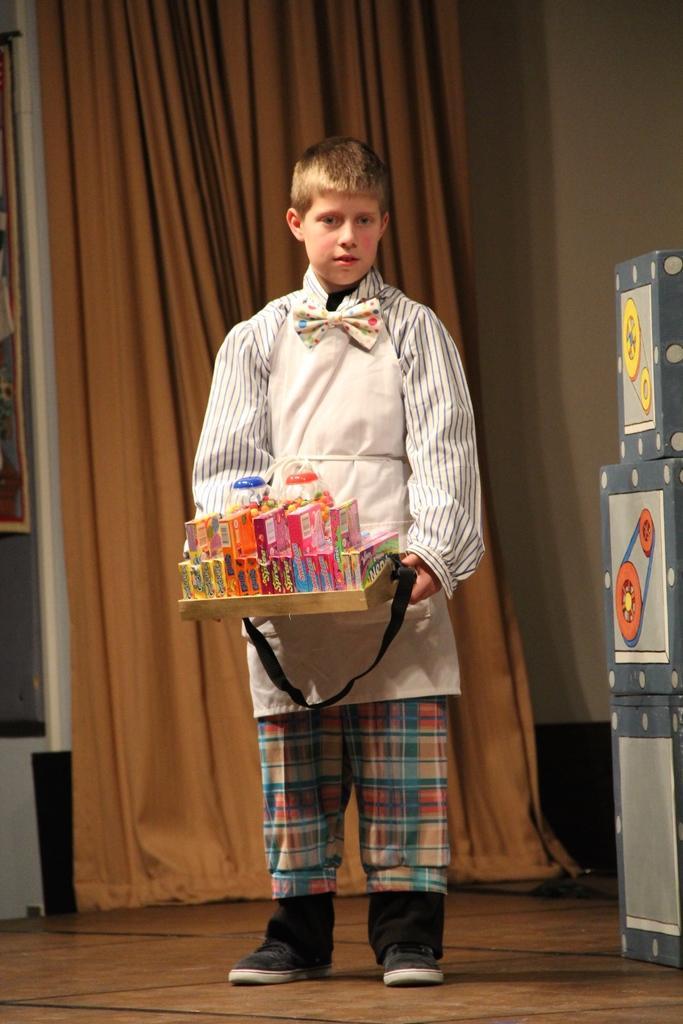Can you describe this image briefly? In this image in the center there is one boy standing, and he is holding one basket and in the basket there are some packets. And on the right side of the image there are some boxes, and in the background there is a curtain and some objects and wall. At the bottom there is floor. 